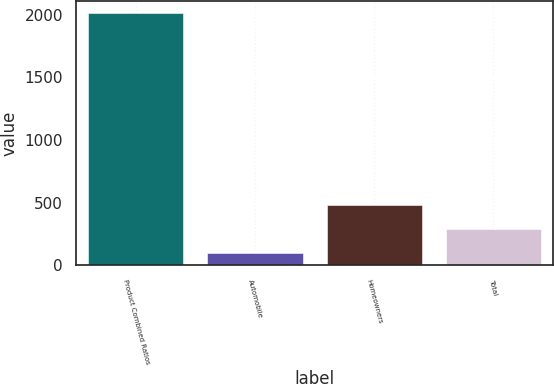Convert chart. <chart><loc_0><loc_0><loc_500><loc_500><bar_chart><fcel>Product Combined Ratios<fcel>Automobile<fcel>Homeowners<fcel>Total<nl><fcel>2010<fcel>98<fcel>480.4<fcel>289.2<nl></chart> 